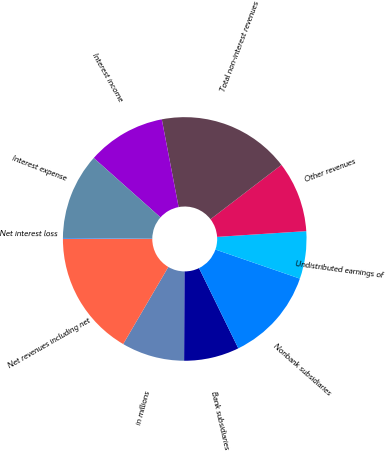Convert chart to OTSL. <chart><loc_0><loc_0><loc_500><loc_500><pie_chart><fcel>in millions<fcel>Bank subsidiaries<fcel>Nonbank subsidiaries<fcel>Undistributed earnings of<fcel>Other revenues<fcel>Total non-interest revenues<fcel>Interest income<fcel>Interest expense<fcel>Net interest loss<fcel>Net revenues including net<nl><fcel>8.35%<fcel>7.33%<fcel>12.47%<fcel>6.3%<fcel>9.38%<fcel>17.61%<fcel>10.41%<fcel>11.44%<fcel>0.12%<fcel>16.58%<nl></chart> 